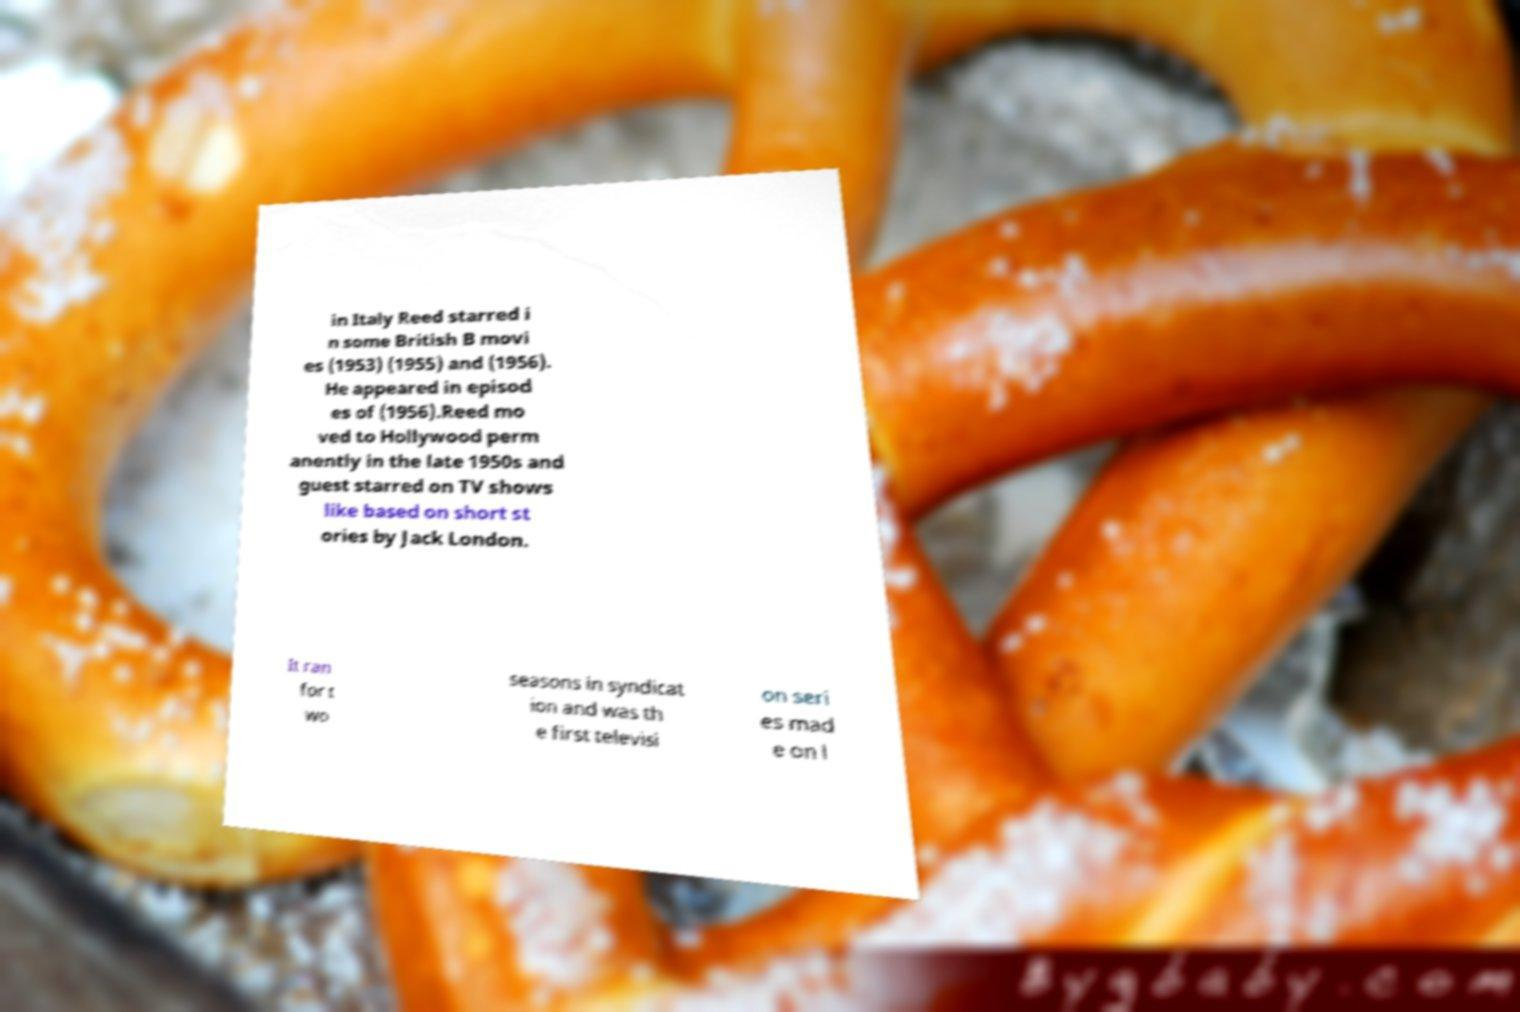Please read and relay the text visible in this image. What does it say? in Italy Reed starred i n some British B movi es (1953) (1955) and (1956). He appeared in episod es of (1956).Reed mo ved to Hollywood perm anently in the late 1950s and guest starred on TV shows like based on short st ories by Jack London. It ran for t wo seasons in syndicat ion and was th e first televisi on seri es mad e on l 